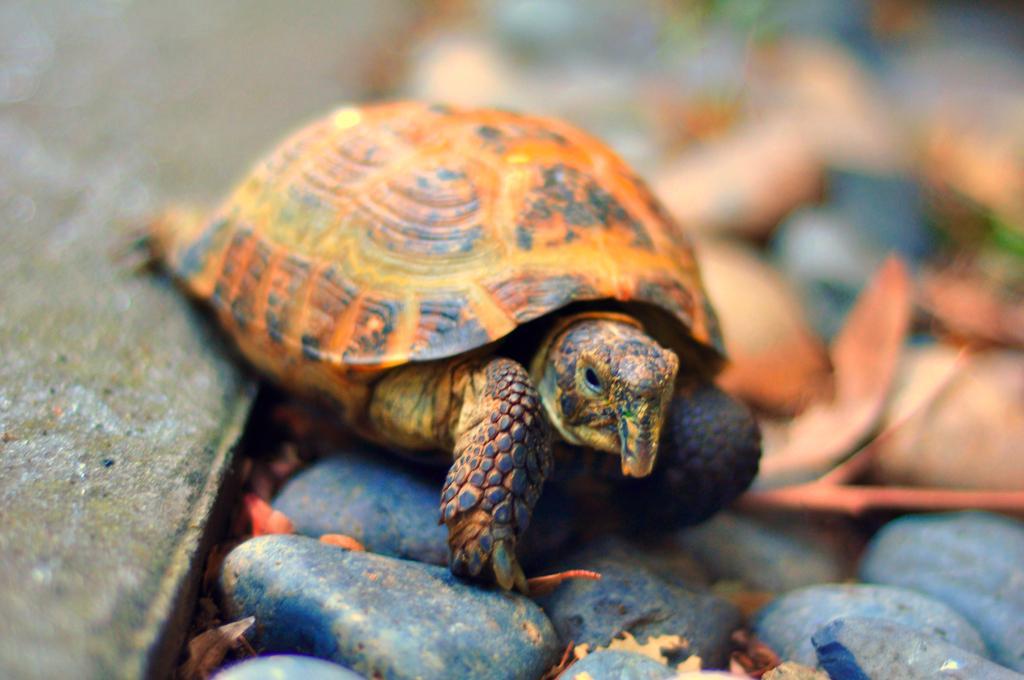How would you summarize this image in a sentence or two? In this picture I can see a tortoise in front and I see number of stones an I see that it is blurred in the background. 